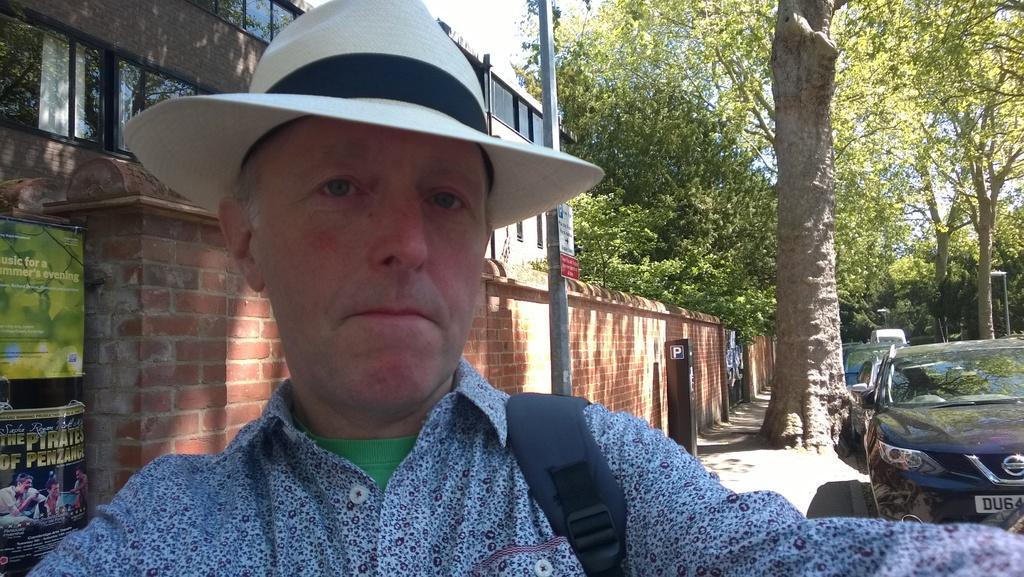In one or two sentences, can you explain what this image depicts? This image is taken outdoors. In the background there is a building with walls and windows. There are a few boards with text on them. There are a few trees with stem, leaves and branches. There are a few poles with street lights. In the middle of the image there is a man. On the right side of the image a few cars are parked on the road. 